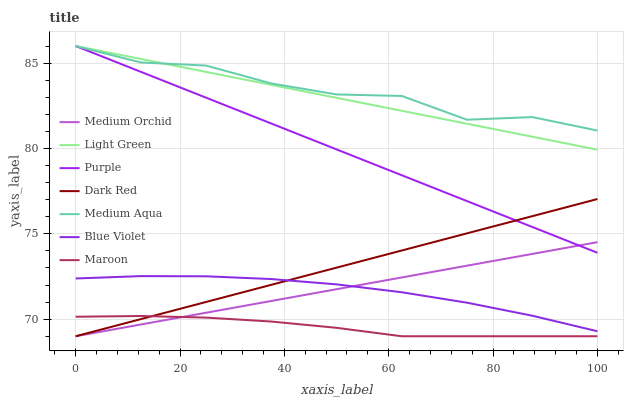Does Maroon have the minimum area under the curve?
Answer yes or no. Yes. Does Medium Aqua have the maximum area under the curve?
Answer yes or no. Yes. Does Dark Red have the minimum area under the curve?
Answer yes or no. No. Does Dark Red have the maximum area under the curve?
Answer yes or no. No. Is Purple the smoothest?
Answer yes or no. Yes. Is Medium Aqua the roughest?
Answer yes or no. Yes. Is Dark Red the smoothest?
Answer yes or no. No. Is Dark Red the roughest?
Answer yes or no. No. Does Medium Aqua have the lowest value?
Answer yes or no. No. Does Light Green have the highest value?
Answer yes or no. Yes. Does Dark Red have the highest value?
Answer yes or no. No. Is Blue Violet less than Medium Aqua?
Answer yes or no. Yes. Is Light Green greater than Medium Orchid?
Answer yes or no. Yes. Does Light Green intersect Medium Aqua?
Answer yes or no. Yes. Is Light Green less than Medium Aqua?
Answer yes or no. No. Is Light Green greater than Medium Aqua?
Answer yes or no. No. Does Blue Violet intersect Medium Aqua?
Answer yes or no. No. 